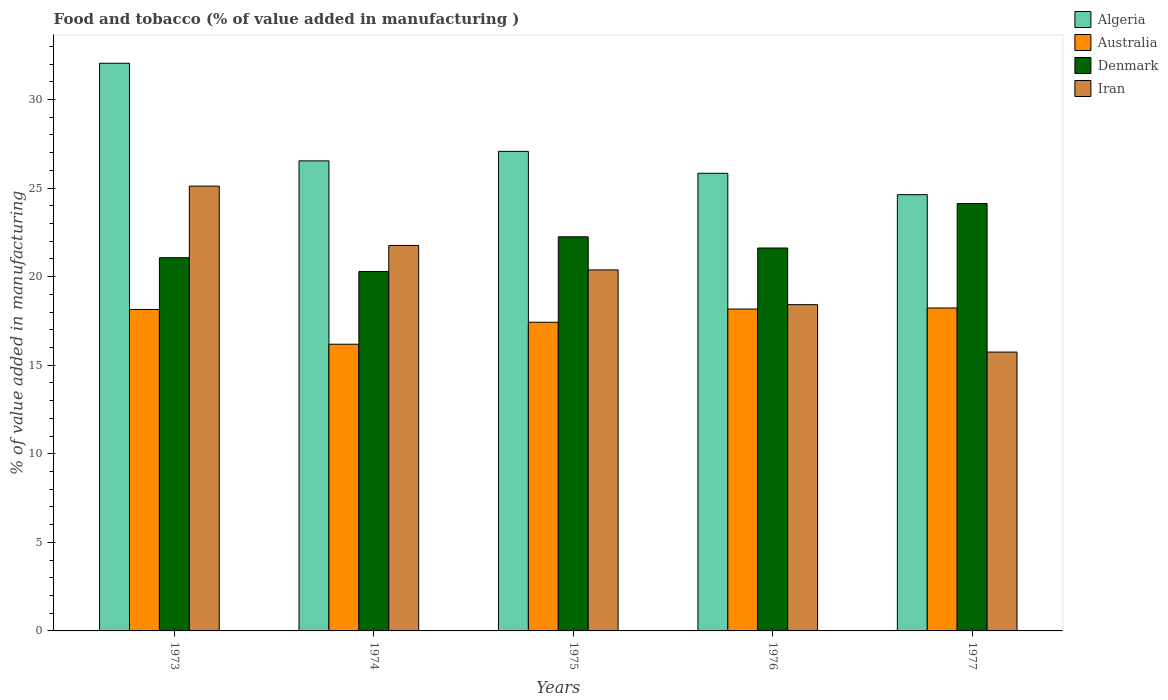How many groups of bars are there?
Offer a terse response. 5. Are the number of bars per tick equal to the number of legend labels?
Keep it short and to the point. Yes. Are the number of bars on each tick of the X-axis equal?
Your answer should be compact. Yes. How many bars are there on the 4th tick from the left?
Provide a short and direct response. 4. What is the label of the 2nd group of bars from the left?
Offer a very short reply. 1974. In how many cases, is the number of bars for a given year not equal to the number of legend labels?
Ensure brevity in your answer.  0. What is the value added in manufacturing food and tobacco in Algeria in 1977?
Your answer should be very brief. 24.63. Across all years, what is the maximum value added in manufacturing food and tobacco in Algeria?
Your answer should be very brief. 32.05. Across all years, what is the minimum value added in manufacturing food and tobacco in Denmark?
Provide a short and direct response. 20.29. In which year was the value added in manufacturing food and tobacco in Australia minimum?
Your answer should be compact. 1974. What is the total value added in manufacturing food and tobacco in Algeria in the graph?
Your answer should be very brief. 136.13. What is the difference between the value added in manufacturing food and tobacco in Algeria in 1974 and that in 1976?
Offer a terse response. 0.7. What is the difference between the value added in manufacturing food and tobacco in Algeria in 1973 and the value added in manufacturing food and tobacco in Denmark in 1977?
Provide a succinct answer. 7.92. What is the average value added in manufacturing food and tobacco in Denmark per year?
Offer a very short reply. 21.87. In the year 1975, what is the difference between the value added in manufacturing food and tobacco in Algeria and value added in manufacturing food and tobacco in Australia?
Keep it short and to the point. 9.65. What is the ratio of the value added in manufacturing food and tobacco in Iran in 1974 to that in 1977?
Give a very brief answer. 1.38. Is the value added in manufacturing food and tobacco in Denmark in 1975 less than that in 1976?
Offer a very short reply. No. Is the difference between the value added in manufacturing food and tobacco in Algeria in 1973 and 1974 greater than the difference between the value added in manufacturing food and tobacco in Australia in 1973 and 1974?
Offer a terse response. Yes. What is the difference between the highest and the second highest value added in manufacturing food and tobacco in Algeria?
Offer a very short reply. 4.97. What is the difference between the highest and the lowest value added in manufacturing food and tobacco in Denmark?
Keep it short and to the point. 3.84. In how many years, is the value added in manufacturing food and tobacco in Denmark greater than the average value added in manufacturing food and tobacco in Denmark taken over all years?
Your answer should be compact. 2. What does the 4th bar from the left in 1976 represents?
Offer a very short reply. Iran. Is it the case that in every year, the sum of the value added in manufacturing food and tobacco in Denmark and value added in manufacturing food and tobacco in Algeria is greater than the value added in manufacturing food and tobacco in Australia?
Your response must be concise. Yes. What is the difference between two consecutive major ticks on the Y-axis?
Make the answer very short. 5. Are the values on the major ticks of Y-axis written in scientific E-notation?
Make the answer very short. No. Does the graph contain any zero values?
Your answer should be compact. No. Does the graph contain grids?
Keep it short and to the point. No. How many legend labels are there?
Ensure brevity in your answer.  4. What is the title of the graph?
Provide a short and direct response. Food and tobacco (% of value added in manufacturing ). Does "Ecuador" appear as one of the legend labels in the graph?
Make the answer very short. No. What is the label or title of the X-axis?
Your answer should be compact. Years. What is the label or title of the Y-axis?
Give a very brief answer. % of value added in manufacturing. What is the % of value added in manufacturing of Algeria in 1973?
Offer a very short reply. 32.05. What is the % of value added in manufacturing of Australia in 1973?
Provide a short and direct response. 18.15. What is the % of value added in manufacturing in Denmark in 1973?
Your answer should be compact. 21.07. What is the % of value added in manufacturing in Iran in 1973?
Offer a very short reply. 25.11. What is the % of value added in manufacturing of Algeria in 1974?
Ensure brevity in your answer.  26.54. What is the % of value added in manufacturing in Australia in 1974?
Your answer should be very brief. 16.19. What is the % of value added in manufacturing of Denmark in 1974?
Ensure brevity in your answer.  20.29. What is the % of value added in manufacturing of Iran in 1974?
Your response must be concise. 21.76. What is the % of value added in manufacturing of Algeria in 1975?
Provide a succinct answer. 27.08. What is the % of value added in manufacturing of Australia in 1975?
Your answer should be very brief. 17.43. What is the % of value added in manufacturing of Denmark in 1975?
Your answer should be compact. 22.25. What is the % of value added in manufacturing in Iran in 1975?
Provide a succinct answer. 20.38. What is the % of value added in manufacturing of Algeria in 1976?
Offer a terse response. 25.84. What is the % of value added in manufacturing in Australia in 1976?
Your response must be concise. 18.17. What is the % of value added in manufacturing of Denmark in 1976?
Offer a very short reply. 21.62. What is the % of value added in manufacturing in Iran in 1976?
Your answer should be very brief. 18.42. What is the % of value added in manufacturing of Algeria in 1977?
Make the answer very short. 24.63. What is the % of value added in manufacturing of Australia in 1977?
Keep it short and to the point. 18.23. What is the % of value added in manufacturing in Denmark in 1977?
Give a very brief answer. 24.13. What is the % of value added in manufacturing in Iran in 1977?
Your answer should be very brief. 15.74. Across all years, what is the maximum % of value added in manufacturing in Algeria?
Your answer should be very brief. 32.05. Across all years, what is the maximum % of value added in manufacturing in Australia?
Your answer should be very brief. 18.23. Across all years, what is the maximum % of value added in manufacturing in Denmark?
Your answer should be compact. 24.13. Across all years, what is the maximum % of value added in manufacturing of Iran?
Your answer should be compact. 25.11. Across all years, what is the minimum % of value added in manufacturing of Algeria?
Your answer should be compact. 24.63. Across all years, what is the minimum % of value added in manufacturing in Australia?
Offer a terse response. 16.19. Across all years, what is the minimum % of value added in manufacturing of Denmark?
Provide a short and direct response. 20.29. Across all years, what is the minimum % of value added in manufacturing of Iran?
Offer a very short reply. 15.74. What is the total % of value added in manufacturing of Algeria in the graph?
Provide a succinct answer. 136.13. What is the total % of value added in manufacturing of Australia in the graph?
Make the answer very short. 88.17. What is the total % of value added in manufacturing in Denmark in the graph?
Ensure brevity in your answer.  109.36. What is the total % of value added in manufacturing of Iran in the graph?
Your response must be concise. 101.42. What is the difference between the % of value added in manufacturing in Algeria in 1973 and that in 1974?
Make the answer very short. 5.51. What is the difference between the % of value added in manufacturing in Australia in 1973 and that in 1974?
Your response must be concise. 1.96. What is the difference between the % of value added in manufacturing of Denmark in 1973 and that in 1974?
Your response must be concise. 0.78. What is the difference between the % of value added in manufacturing in Iran in 1973 and that in 1974?
Your answer should be compact. 3.35. What is the difference between the % of value added in manufacturing in Algeria in 1973 and that in 1975?
Your response must be concise. 4.97. What is the difference between the % of value added in manufacturing of Australia in 1973 and that in 1975?
Keep it short and to the point. 0.72. What is the difference between the % of value added in manufacturing in Denmark in 1973 and that in 1975?
Offer a very short reply. -1.18. What is the difference between the % of value added in manufacturing in Iran in 1973 and that in 1975?
Provide a short and direct response. 4.73. What is the difference between the % of value added in manufacturing of Algeria in 1973 and that in 1976?
Provide a succinct answer. 6.21. What is the difference between the % of value added in manufacturing in Australia in 1973 and that in 1976?
Your answer should be very brief. -0.02. What is the difference between the % of value added in manufacturing of Denmark in 1973 and that in 1976?
Offer a very short reply. -0.55. What is the difference between the % of value added in manufacturing in Iran in 1973 and that in 1976?
Provide a short and direct response. 6.69. What is the difference between the % of value added in manufacturing in Algeria in 1973 and that in 1977?
Offer a very short reply. 7.42. What is the difference between the % of value added in manufacturing in Australia in 1973 and that in 1977?
Provide a succinct answer. -0.08. What is the difference between the % of value added in manufacturing of Denmark in 1973 and that in 1977?
Keep it short and to the point. -3.06. What is the difference between the % of value added in manufacturing of Iran in 1973 and that in 1977?
Make the answer very short. 9.37. What is the difference between the % of value added in manufacturing of Algeria in 1974 and that in 1975?
Keep it short and to the point. -0.54. What is the difference between the % of value added in manufacturing of Australia in 1974 and that in 1975?
Give a very brief answer. -1.24. What is the difference between the % of value added in manufacturing of Denmark in 1974 and that in 1975?
Make the answer very short. -1.96. What is the difference between the % of value added in manufacturing of Iran in 1974 and that in 1975?
Keep it short and to the point. 1.38. What is the difference between the % of value added in manufacturing in Algeria in 1974 and that in 1976?
Provide a short and direct response. 0.7. What is the difference between the % of value added in manufacturing in Australia in 1974 and that in 1976?
Ensure brevity in your answer.  -1.99. What is the difference between the % of value added in manufacturing of Denmark in 1974 and that in 1976?
Offer a terse response. -1.33. What is the difference between the % of value added in manufacturing in Iran in 1974 and that in 1976?
Give a very brief answer. 3.34. What is the difference between the % of value added in manufacturing in Algeria in 1974 and that in 1977?
Ensure brevity in your answer.  1.91. What is the difference between the % of value added in manufacturing in Australia in 1974 and that in 1977?
Provide a short and direct response. -2.05. What is the difference between the % of value added in manufacturing in Denmark in 1974 and that in 1977?
Your answer should be compact. -3.84. What is the difference between the % of value added in manufacturing of Iran in 1974 and that in 1977?
Ensure brevity in your answer.  6.02. What is the difference between the % of value added in manufacturing in Algeria in 1975 and that in 1976?
Offer a very short reply. 1.24. What is the difference between the % of value added in manufacturing of Australia in 1975 and that in 1976?
Your response must be concise. -0.75. What is the difference between the % of value added in manufacturing in Denmark in 1975 and that in 1976?
Your answer should be very brief. 0.63. What is the difference between the % of value added in manufacturing of Iran in 1975 and that in 1976?
Your answer should be very brief. 1.96. What is the difference between the % of value added in manufacturing of Algeria in 1975 and that in 1977?
Give a very brief answer. 2.44. What is the difference between the % of value added in manufacturing in Australia in 1975 and that in 1977?
Make the answer very short. -0.81. What is the difference between the % of value added in manufacturing in Denmark in 1975 and that in 1977?
Keep it short and to the point. -1.88. What is the difference between the % of value added in manufacturing of Iran in 1975 and that in 1977?
Make the answer very short. 4.64. What is the difference between the % of value added in manufacturing of Algeria in 1976 and that in 1977?
Provide a succinct answer. 1.21. What is the difference between the % of value added in manufacturing in Australia in 1976 and that in 1977?
Offer a very short reply. -0.06. What is the difference between the % of value added in manufacturing in Denmark in 1976 and that in 1977?
Your answer should be compact. -2.51. What is the difference between the % of value added in manufacturing in Iran in 1976 and that in 1977?
Your response must be concise. 2.68. What is the difference between the % of value added in manufacturing of Algeria in 1973 and the % of value added in manufacturing of Australia in 1974?
Keep it short and to the point. 15.86. What is the difference between the % of value added in manufacturing of Algeria in 1973 and the % of value added in manufacturing of Denmark in 1974?
Give a very brief answer. 11.76. What is the difference between the % of value added in manufacturing of Algeria in 1973 and the % of value added in manufacturing of Iran in 1974?
Ensure brevity in your answer.  10.29. What is the difference between the % of value added in manufacturing in Australia in 1973 and the % of value added in manufacturing in Denmark in 1974?
Keep it short and to the point. -2.14. What is the difference between the % of value added in manufacturing in Australia in 1973 and the % of value added in manufacturing in Iran in 1974?
Your response must be concise. -3.61. What is the difference between the % of value added in manufacturing of Denmark in 1973 and the % of value added in manufacturing of Iran in 1974?
Make the answer very short. -0.69. What is the difference between the % of value added in manufacturing in Algeria in 1973 and the % of value added in manufacturing in Australia in 1975?
Provide a succinct answer. 14.62. What is the difference between the % of value added in manufacturing in Algeria in 1973 and the % of value added in manufacturing in Denmark in 1975?
Your response must be concise. 9.8. What is the difference between the % of value added in manufacturing of Algeria in 1973 and the % of value added in manufacturing of Iran in 1975?
Offer a terse response. 11.67. What is the difference between the % of value added in manufacturing of Australia in 1973 and the % of value added in manufacturing of Denmark in 1975?
Give a very brief answer. -4.1. What is the difference between the % of value added in manufacturing of Australia in 1973 and the % of value added in manufacturing of Iran in 1975?
Ensure brevity in your answer.  -2.23. What is the difference between the % of value added in manufacturing in Denmark in 1973 and the % of value added in manufacturing in Iran in 1975?
Keep it short and to the point. 0.69. What is the difference between the % of value added in manufacturing of Algeria in 1973 and the % of value added in manufacturing of Australia in 1976?
Your response must be concise. 13.88. What is the difference between the % of value added in manufacturing of Algeria in 1973 and the % of value added in manufacturing of Denmark in 1976?
Your response must be concise. 10.43. What is the difference between the % of value added in manufacturing of Algeria in 1973 and the % of value added in manufacturing of Iran in 1976?
Ensure brevity in your answer.  13.63. What is the difference between the % of value added in manufacturing of Australia in 1973 and the % of value added in manufacturing of Denmark in 1976?
Keep it short and to the point. -3.47. What is the difference between the % of value added in manufacturing in Australia in 1973 and the % of value added in manufacturing in Iran in 1976?
Give a very brief answer. -0.27. What is the difference between the % of value added in manufacturing in Denmark in 1973 and the % of value added in manufacturing in Iran in 1976?
Ensure brevity in your answer.  2.65. What is the difference between the % of value added in manufacturing of Algeria in 1973 and the % of value added in manufacturing of Australia in 1977?
Your answer should be compact. 13.82. What is the difference between the % of value added in manufacturing in Algeria in 1973 and the % of value added in manufacturing in Denmark in 1977?
Keep it short and to the point. 7.92. What is the difference between the % of value added in manufacturing in Algeria in 1973 and the % of value added in manufacturing in Iran in 1977?
Your answer should be very brief. 16.31. What is the difference between the % of value added in manufacturing of Australia in 1973 and the % of value added in manufacturing of Denmark in 1977?
Ensure brevity in your answer.  -5.98. What is the difference between the % of value added in manufacturing of Australia in 1973 and the % of value added in manufacturing of Iran in 1977?
Make the answer very short. 2.41. What is the difference between the % of value added in manufacturing of Denmark in 1973 and the % of value added in manufacturing of Iran in 1977?
Provide a short and direct response. 5.33. What is the difference between the % of value added in manufacturing in Algeria in 1974 and the % of value added in manufacturing in Australia in 1975?
Provide a succinct answer. 9.11. What is the difference between the % of value added in manufacturing of Algeria in 1974 and the % of value added in manufacturing of Denmark in 1975?
Your response must be concise. 4.29. What is the difference between the % of value added in manufacturing of Algeria in 1974 and the % of value added in manufacturing of Iran in 1975?
Your answer should be very brief. 6.16. What is the difference between the % of value added in manufacturing in Australia in 1974 and the % of value added in manufacturing in Denmark in 1975?
Keep it short and to the point. -6.07. What is the difference between the % of value added in manufacturing in Australia in 1974 and the % of value added in manufacturing in Iran in 1975?
Make the answer very short. -4.2. What is the difference between the % of value added in manufacturing in Denmark in 1974 and the % of value added in manufacturing in Iran in 1975?
Provide a succinct answer. -0.09. What is the difference between the % of value added in manufacturing in Algeria in 1974 and the % of value added in manufacturing in Australia in 1976?
Keep it short and to the point. 8.37. What is the difference between the % of value added in manufacturing of Algeria in 1974 and the % of value added in manufacturing of Denmark in 1976?
Provide a short and direct response. 4.92. What is the difference between the % of value added in manufacturing in Algeria in 1974 and the % of value added in manufacturing in Iran in 1976?
Your response must be concise. 8.12. What is the difference between the % of value added in manufacturing in Australia in 1974 and the % of value added in manufacturing in Denmark in 1976?
Your response must be concise. -5.43. What is the difference between the % of value added in manufacturing in Australia in 1974 and the % of value added in manufacturing in Iran in 1976?
Make the answer very short. -2.23. What is the difference between the % of value added in manufacturing of Denmark in 1974 and the % of value added in manufacturing of Iran in 1976?
Offer a very short reply. 1.87. What is the difference between the % of value added in manufacturing in Algeria in 1974 and the % of value added in manufacturing in Australia in 1977?
Provide a succinct answer. 8.31. What is the difference between the % of value added in manufacturing of Algeria in 1974 and the % of value added in manufacturing of Denmark in 1977?
Your answer should be very brief. 2.41. What is the difference between the % of value added in manufacturing of Algeria in 1974 and the % of value added in manufacturing of Iran in 1977?
Your answer should be very brief. 10.8. What is the difference between the % of value added in manufacturing of Australia in 1974 and the % of value added in manufacturing of Denmark in 1977?
Give a very brief answer. -7.94. What is the difference between the % of value added in manufacturing in Australia in 1974 and the % of value added in manufacturing in Iran in 1977?
Offer a terse response. 0.44. What is the difference between the % of value added in manufacturing in Denmark in 1974 and the % of value added in manufacturing in Iran in 1977?
Make the answer very short. 4.55. What is the difference between the % of value added in manufacturing of Algeria in 1975 and the % of value added in manufacturing of Australia in 1976?
Offer a very short reply. 8.9. What is the difference between the % of value added in manufacturing of Algeria in 1975 and the % of value added in manufacturing of Denmark in 1976?
Keep it short and to the point. 5.46. What is the difference between the % of value added in manufacturing in Algeria in 1975 and the % of value added in manufacturing in Iran in 1976?
Your answer should be compact. 8.66. What is the difference between the % of value added in manufacturing in Australia in 1975 and the % of value added in manufacturing in Denmark in 1976?
Provide a succinct answer. -4.19. What is the difference between the % of value added in manufacturing of Australia in 1975 and the % of value added in manufacturing of Iran in 1976?
Give a very brief answer. -0.99. What is the difference between the % of value added in manufacturing of Denmark in 1975 and the % of value added in manufacturing of Iran in 1976?
Provide a short and direct response. 3.83. What is the difference between the % of value added in manufacturing of Algeria in 1975 and the % of value added in manufacturing of Australia in 1977?
Keep it short and to the point. 8.84. What is the difference between the % of value added in manufacturing of Algeria in 1975 and the % of value added in manufacturing of Denmark in 1977?
Offer a very short reply. 2.95. What is the difference between the % of value added in manufacturing in Algeria in 1975 and the % of value added in manufacturing in Iran in 1977?
Offer a very short reply. 11.33. What is the difference between the % of value added in manufacturing in Australia in 1975 and the % of value added in manufacturing in Denmark in 1977?
Ensure brevity in your answer.  -6.7. What is the difference between the % of value added in manufacturing of Australia in 1975 and the % of value added in manufacturing of Iran in 1977?
Your answer should be very brief. 1.68. What is the difference between the % of value added in manufacturing in Denmark in 1975 and the % of value added in manufacturing in Iran in 1977?
Keep it short and to the point. 6.51. What is the difference between the % of value added in manufacturing in Algeria in 1976 and the % of value added in manufacturing in Australia in 1977?
Your answer should be very brief. 7.6. What is the difference between the % of value added in manufacturing of Algeria in 1976 and the % of value added in manufacturing of Denmark in 1977?
Your response must be concise. 1.71. What is the difference between the % of value added in manufacturing in Algeria in 1976 and the % of value added in manufacturing in Iran in 1977?
Offer a very short reply. 10.09. What is the difference between the % of value added in manufacturing in Australia in 1976 and the % of value added in manufacturing in Denmark in 1977?
Offer a very short reply. -5.96. What is the difference between the % of value added in manufacturing of Australia in 1976 and the % of value added in manufacturing of Iran in 1977?
Keep it short and to the point. 2.43. What is the difference between the % of value added in manufacturing of Denmark in 1976 and the % of value added in manufacturing of Iran in 1977?
Provide a short and direct response. 5.88. What is the average % of value added in manufacturing in Algeria per year?
Your answer should be compact. 27.23. What is the average % of value added in manufacturing of Australia per year?
Your response must be concise. 17.63. What is the average % of value added in manufacturing in Denmark per year?
Keep it short and to the point. 21.87. What is the average % of value added in manufacturing in Iran per year?
Provide a succinct answer. 20.28. In the year 1973, what is the difference between the % of value added in manufacturing in Algeria and % of value added in manufacturing in Australia?
Your answer should be very brief. 13.9. In the year 1973, what is the difference between the % of value added in manufacturing in Algeria and % of value added in manufacturing in Denmark?
Your answer should be compact. 10.98. In the year 1973, what is the difference between the % of value added in manufacturing of Algeria and % of value added in manufacturing of Iran?
Your answer should be very brief. 6.94. In the year 1973, what is the difference between the % of value added in manufacturing in Australia and % of value added in manufacturing in Denmark?
Offer a terse response. -2.92. In the year 1973, what is the difference between the % of value added in manufacturing of Australia and % of value added in manufacturing of Iran?
Your response must be concise. -6.96. In the year 1973, what is the difference between the % of value added in manufacturing in Denmark and % of value added in manufacturing in Iran?
Ensure brevity in your answer.  -4.04. In the year 1974, what is the difference between the % of value added in manufacturing of Algeria and % of value added in manufacturing of Australia?
Ensure brevity in your answer.  10.35. In the year 1974, what is the difference between the % of value added in manufacturing of Algeria and % of value added in manufacturing of Denmark?
Offer a terse response. 6.25. In the year 1974, what is the difference between the % of value added in manufacturing of Algeria and % of value added in manufacturing of Iran?
Provide a short and direct response. 4.78. In the year 1974, what is the difference between the % of value added in manufacturing of Australia and % of value added in manufacturing of Denmark?
Your answer should be compact. -4.11. In the year 1974, what is the difference between the % of value added in manufacturing in Australia and % of value added in manufacturing in Iran?
Your answer should be compact. -5.58. In the year 1974, what is the difference between the % of value added in manufacturing of Denmark and % of value added in manufacturing of Iran?
Make the answer very short. -1.47. In the year 1975, what is the difference between the % of value added in manufacturing of Algeria and % of value added in manufacturing of Australia?
Provide a succinct answer. 9.65. In the year 1975, what is the difference between the % of value added in manufacturing in Algeria and % of value added in manufacturing in Denmark?
Offer a terse response. 4.82. In the year 1975, what is the difference between the % of value added in manufacturing of Algeria and % of value added in manufacturing of Iran?
Offer a terse response. 6.69. In the year 1975, what is the difference between the % of value added in manufacturing in Australia and % of value added in manufacturing in Denmark?
Ensure brevity in your answer.  -4.82. In the year 1975, what is the difference between the % of value added in manufacturing in Australia and % of value added in manufacturing in Iran?
Offer a very short reply. -2.95. In the year 1975, what is the difference between the % of value added in manufacturing of Denmark and % of value added in manufacturing of Iran?
Offer a terse response. 1.87. In the year 1976, what is the difference between the % of value added in manufacturing in Algeria and % of value added in manufacturing in Australia?
Make the answer very short. 7.66. In the year 1976, what is the difference between the % of value added in manufacturing in Algeria and % of value added in manufacturing in Denmark?
Provide a short and direct response. 4.22. In the year 1976, what is the difference between the % of value added in manufacturing in Algeria and % of value added in manufacturing in Iran?
Provide a succinct answer. 7.42. In the year 1976, what is the difference between the % of value added in manufacturing of Australia and % of value added in manufacturing of Denmark?
Keep it short and to the point. -3.45. In the year 1976, what is the difference between the % of value added in manufacturing of Australia and % of value added in manufacturing of Iran?
Make the answer very short. -0.25. In the year 1976, what is the difference between the % of value added in manufacturing of Denmark and % of value added in manufacturing of Iran?
Your answer should be very brief. 3.2. In the year 1977, what is the difference between the % of value added in manufacturing of Algeria and % of value added in manufacturing of Australia?
Ensure brevity in your answer.  6.4. In the year 1977, what is the difference between the % of value added in manufacturing in Algeria and % of value added in manufacturing in Denmark?
Offer a terse response. 0.5. In the year 1977, what is the difference between the % of value added in manufacturing of Algeria and % of value added in manufacturing of Iran?
Provide a short and direct response. 8.89. In the year 1977, what is the difference between the % of value added in manufacturing of Australia and % of value added in manufacturing of Denmark?
Give a very brief answer. -5.9. In the year 1977, what is the difference between the % of value added in manufacturing in Australia and % of value added in manufacturing in Iran?
Make the answer very short. 2.49. In the year 1977, what is the difference between the % of value added in manufacturing of Denmark and % of value added in manufacturing of Iran?
Provide a succinct answer. 8.39. What is the ratio of the % of value added in manufacturing in Algeria in 1973 to that in 1974?
Ensure brevity in your answer.  1.21. What is the ratio of the % of value added in manufacturing in Australia in 1973 to that in 1974?
Provide a short and direct response. 1.12. What is the ratio of the % of value added in manufacturing of Denmark in 1973 to that in 1974?
Your response must be concise. 1.04. What is the ratio of the % of value added in manufacturing in Iran in 1973 to that in 1974?
Make the answer very short. 1.15. What is the ratio of the % of value added in manufacturing of Algeria in 1973 to that in 1975?
Offer a terse response. 1.18. What is the ratio of the % of value added in manufacturing of Australia in 1973 to that in 1975?
Offer a terse response. 1.04. What is the ratio of the % of value added in manufacturing in Denmark in 1973 to that in 1975?
Give a very brief answer. 0.95. What is the ratio of the % of value added in manufacturing in Iran in 1973 to that in 1975?
Offer a terse response. 1.23. What is the ratio of the % of value added in manufacturing of Algeria in 1973 to that in 1976?
Ensure brevity in your answer.  1.24. What is the ratio of the % of value added in manufacturing of Australia in 1973 to that in 1976?
Give a very brief answer. 1. What is the ratio of the % of value added in manufacturing of Denmark in 1973 to that in 1976?
Keep it short and to the point. 0.97. What is the ratio of the % of value added in manufacturing in Iran in 1973 to that in 1976?
Provide a succinct answer. 1.36. What is the ratio of the % of value added in manufacturing of Algeria in 1973 to that in 1977?
Offer a terse response. 1.3. What is the ratio of the % of value added in manufacturing of Denmark in 1973 to that in 1977?
Make the answer very short. 0.87. What is the ratio of the % of value added in manufacturing of Iran in 1973 to that in 1977?
Offer a very short reply. 1.6. What is the ratio of the % of value added in manufacturing in Algeria in 1974 to that in 1975?
Your answer should be compact. 0.98. What is the ratio of the % of value added in manufacturing in Australia in 1974 to that in 1975?
Your answer should be very brief. 0.93. What is the ratio of the % of value added in manufacturing of Denmark in 1974 to that in 1975?
Give a very brief answer. 0.91. What is the ratio of the % of value added in manufacturing of Iran in 1974 to that in 1975?
Offer a terse response. 1.07. What is the ratio of the % of value added in manufacturing of Algeria in 1974 to that in 1976?
Give a very brief answer. 1.03. What is the ratio of the % of value added in manufacturing in Australia in 1974 to that in 1976?
Provide a succinct answer. 0.89. What is the ratio of the % of value added in manufacturing in Denmark in 1974 to that in 1976?
Offer a terse response. 0.94. What is the ratio of the % of value added in manufacturing of Iran in 1974 to that in 1976?
Your response must be concise. 1.18. What is the ratio of the % of value added in manufacturing in Algeria in 1974 to that in 1977?
Your response must be concise. 1.08. What is the ratio of the % of value added in manufacturing of Australia in 1974 to that in 1977?
Provide a short and direct response. 0.89. What is the ratio of the % of value added in manufacturing in Denmark in 1974 to that in 1977?
Provide a succinct answer. 0.84. What is the ratio of the % of value added in manufacturing of Iran in 1974 to that in 1977?
Provide a short and direct response. 1.38. What is the ratio of the % of value added in manufacturing in Algeria in 1975 to that in 1976?
Make the answer very short. 1.05. What is the ratio of the % of value added in manufacturing in Denmark in 1975 to that in 1976?
Make the answer very short. 1.03. What is the ratio of the % of value added in manufacturing of Iran in 1975 to that in 1976?
Make the answer very short. 1.11. What is the ratio of the % of value added in manufacturing in Algeria in 1975 to that in 1977?
Offer a terse response. 1.1. What is the ratio of the % of value added in manufacturing of Australia in 1975 to that in 1977?
Provide a short and direct response. 0.96. What is the ratio of the % of value added in manufacturing of Denmark in 1975 to that in 1977?
Keep it short and to the point. 0.92. What is the ratio of the % of value added in manufacturing of Iran in 1975 to that in 1977?
Your answer should be very brief. 1.29. What is the ratio of the % of value added in manufacturing in Algeria in 1976 to that in 1977?
Make the answer very short. 1.05. What is the ratio of the % of value added in manufacturing of Denmark in 1976 to that in 1977?
Offer a very short reply. 0.9. What is the ratio of the % of value added in manufacturing in Iran in 1976 to that in 1977?
Your answer should be compact. 1.17. What is the difference between the highest and the second highest % of value added in manufacturing of Algeria?
Your answer should be very brief. 4.97. What is the difference between the highest and the second highest % of value added in manufacturing in Australia?
Offer a very short reply. 0.06. What is the difference between the highest and the second highest % of value added in manufacturing in Denmark?
Keep it short and to the point. 1.88. What is the difference between the highest and the second highest % of value added in manufacturing of Iran?
Ensure brevity in your answer.  3.35. What is the difference between the highest and the lowest % of value added in manufacturing of Algeria?
Offer a terse response. 7.42. What is the difference between the highest and the lowest % of value added in manufacturing in Australia?
Ensure brevity in your answer.  2.05. What is the difference between the highest and the lowest % of value added in manufacturing of Denmark?
Your answer should be compact. 3.84. What is the difference between the highest and the lowest % of value added in manufacturing in Iran?
Offer a terse response. 9.37. 